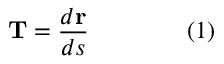<formula> <loc_0><loc_0><loc_500><loc_500>T = { \frac { d r } { d s } } \quad ( 1 )</formula> 